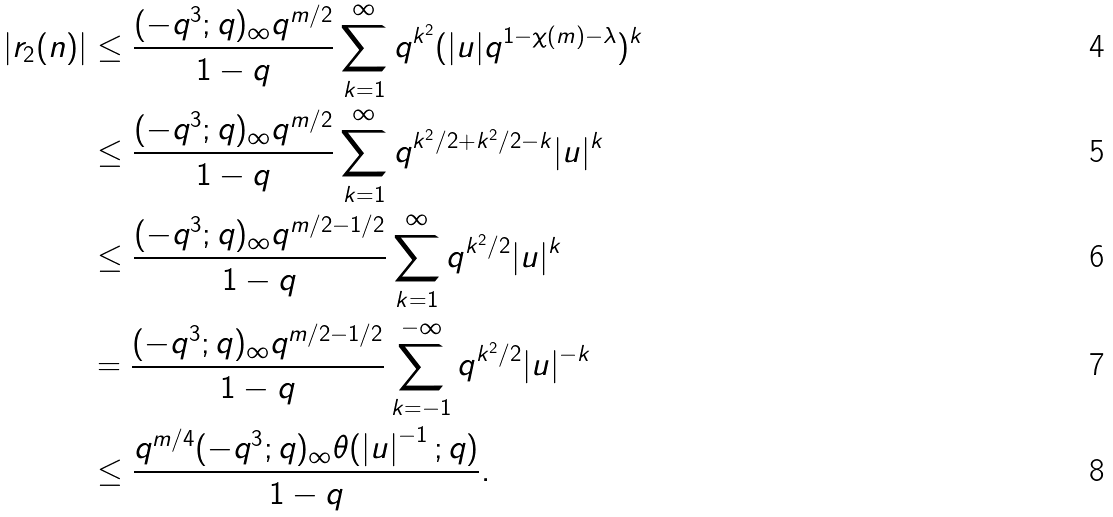Convert formula to latex. <formula><loc_0><loc_0><loc_500><loc_500>| r _ { 2 } ( n ) | & \leq \frac { ( - q ^ { 3 } ; q ) _ { \infty } q ^ { m / 2 } } { 1 - q } \sum _ { k = 1 } ^ { \infty } q ^ { k ^ { 2 } } ( | u | q ^ { 1 - \chi ( m ) - \lambda } ) ^ { k } \\ & \leq \frac { ( - q ^ { 3 } ; q ) _ { \infty } q ^ { m / 2 } } { 1 - q } \sum _ { k = 1 } ^ { \infty } q ^ { k ^ { 2 } / 2 + k ^ { 2 } / 2 - k } | u | ^ { k } \\ & \leq \frac { ( - q ^ { 3 } ; q ) _ { \infty } q ^ { m / 2 - 1 / 2 } } { 1 - q } \sum _ { k = 1 } ^ { \infty } q ^ { k ^ { 2 } / 2 } | u | ^ { k } \\ & = \frac { ( - q ^ { 3 } ; q ) _ { \infty } q ^ { m / 2 - 1 / 2 } } { 1 - q } \sum _ { k = - 1 } ^ { - \infty } q ^ { k ^ { 2 } / 2 } | u | ^ { - k } \\ & \leq \frac { q ^ { m / 4 } ( - q ^ { 3 } ; q ) _ { \infty } \theta ( \left | u \right | ^ { - 1 } ; q ) } { 1 - q } .</formula> 